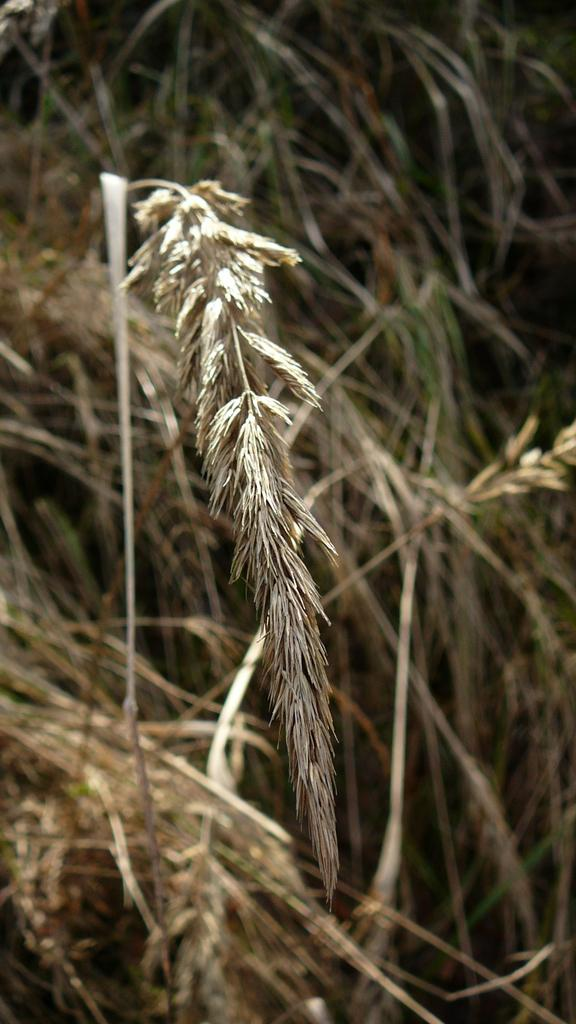What type of living organisms can be seen in the image? Plants can be seen in the image. What is the opinion of the woman about the rat in the image? There is no woman or rat present in the image, so it is not possible to determine the woman's opinion about the rat. 